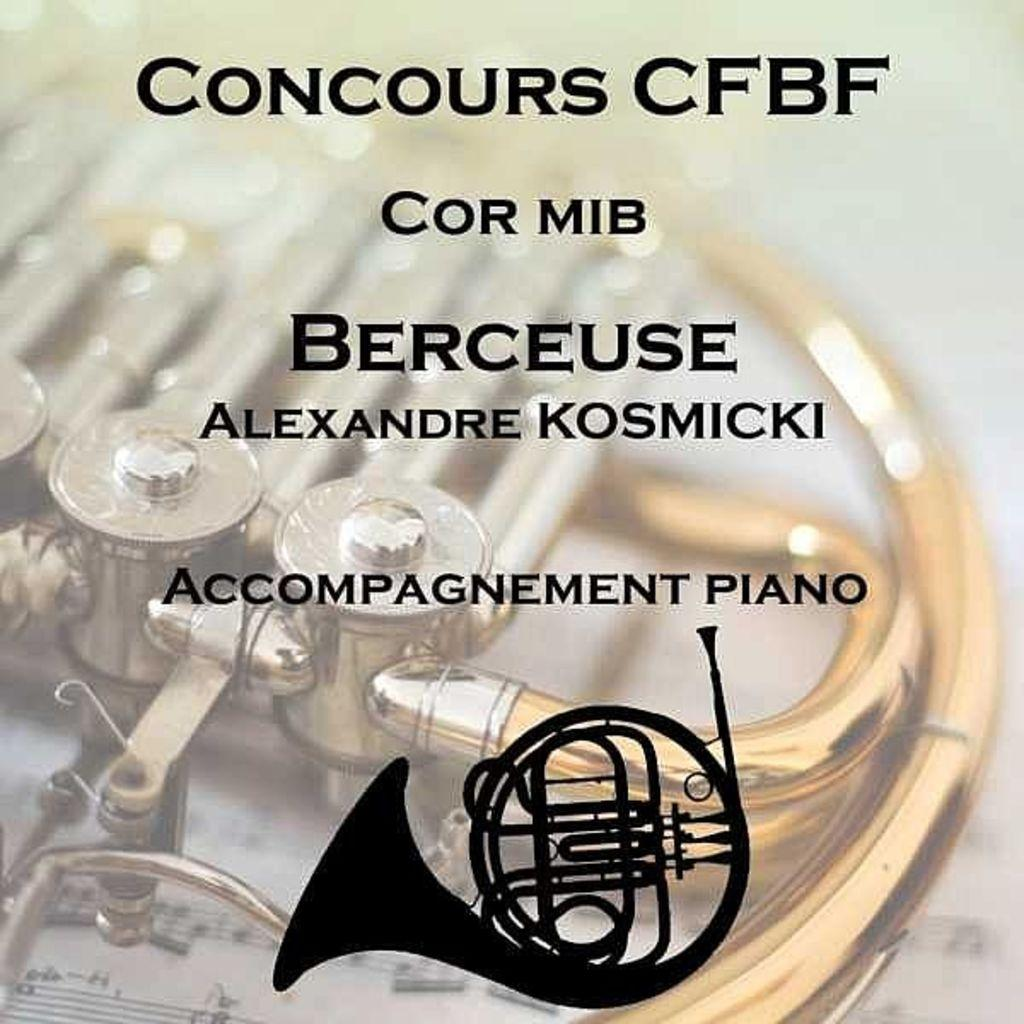What is present in the image that contains text? There is a poster in the image that contains text. What is featured on the poster besides the text? The poster has a logo of a musical instrument. Can you describe the musical instrument depicted in the logo? Unfortunately, the specific musical instrument cannot be determined from the provided facts. What else can be seen in the background of the image? There is a musical instrument on a paper in the background of the image. What color is the wish in the image? There is no mention of a wish in the image, so it cannot be determined what color it might be. 